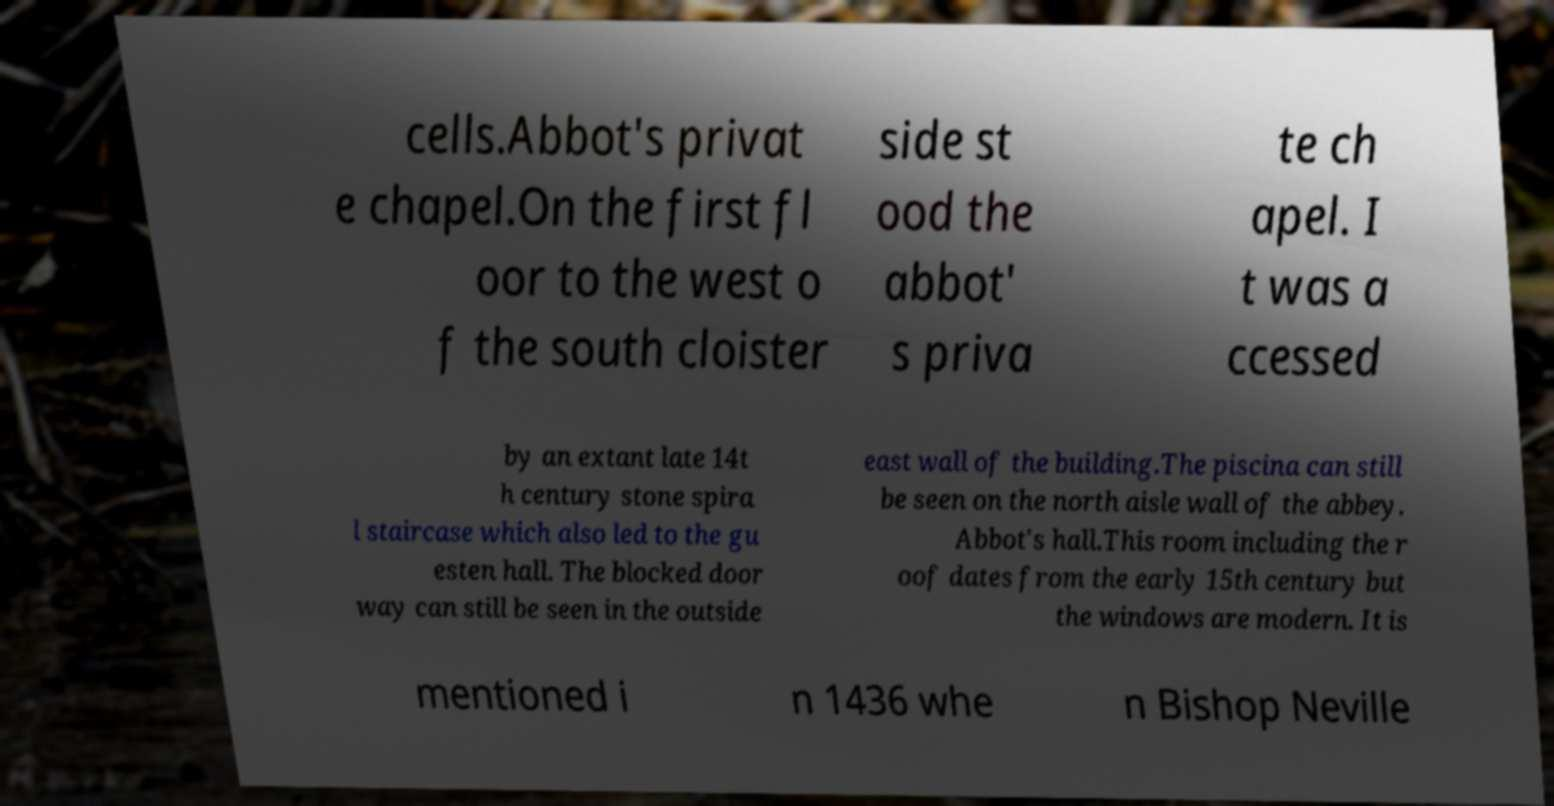Can you read and provide the text displayed in the image?This photo seems to have some interesting text. Can you extract and type it out for me? cells.Abbot's privat e chapel.On the first fl oor to the west o f the south cloister side st ood the abbot' s priva te ch apel. I t was a ccessed by an extant late 14t h century stone spira l staircase which also led to the gu esten hall. The blocked door way can still be seen in the outside east wall of the building.The piscina can still be seen on the north aisle wall of the abbey. Abbot's hall.This room including the r oof dates from the early 15th century but the windows are modern. It is mentioned i n 1436 whe n Bishop Neville 